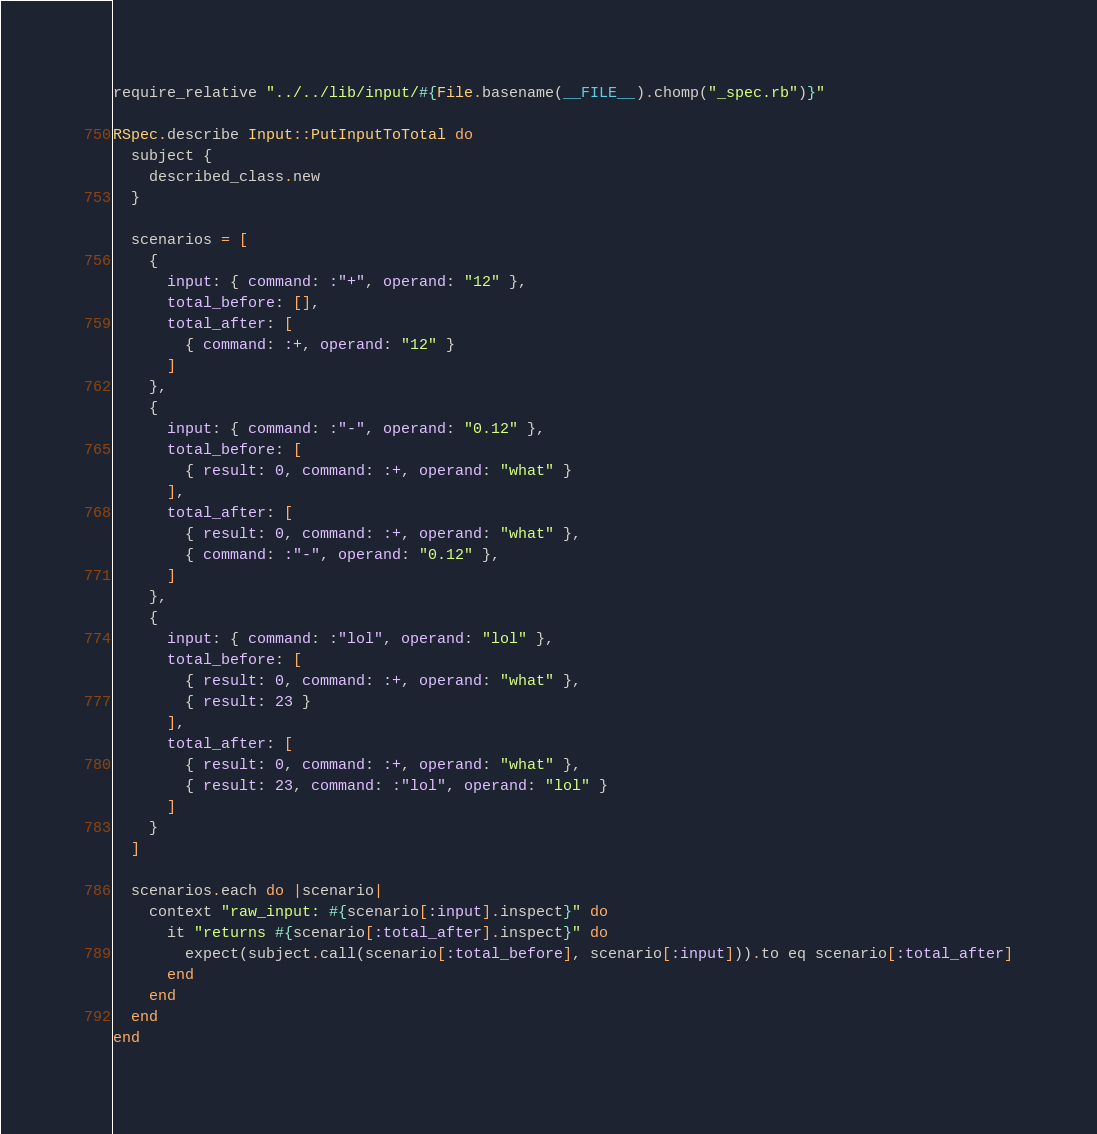<code> <loc_0><loc_0><loc_500><loc_500><_Ruby_>require_relative "../../lib/input/#{File.basename(__FILE__).chomp("_spec.rb")}"

RSpec.describe Input::PutInputToTotal do
  subject {
    described_class.new
  }

  scenarios = [
    {
      input: { command: :"+", operand: "12" },
      total_before: [],
      total_after: [
        { command: :+, operand: "12" }
      ]
    },
    {
      input: { command: :"-", operand: "0.12" },
      total_before: [
        { result: 0, command: :+, operand: "what" }
      ],
      total_after: [
        { result: 0, command: :+, operand: "what" },
        { command: :"-", operand: "0.12" },
      ]
    },
    {
      input: { command: :"lol", operand: "lol" },
      total_before: [
        { result: 0, command: :+, operand: "what" },
        { result: 23 }
      ],
      total_after: [
        { result: 0, command: :+, operand: "what" },
        { result: 23, command: :"lol", operand: "lol" }
      ]
    }
  ]

  scenarios.each do |scenario|
    context "raw_input: #{scenario[:input].inspect}" do
      it "returns #{scenario[:total_after].inspect}" do
        expect(subject.call(scenario[:total_before], scenario[:input])).to eq scenario[:total_after]
      end
    end
  end
end
</code> 